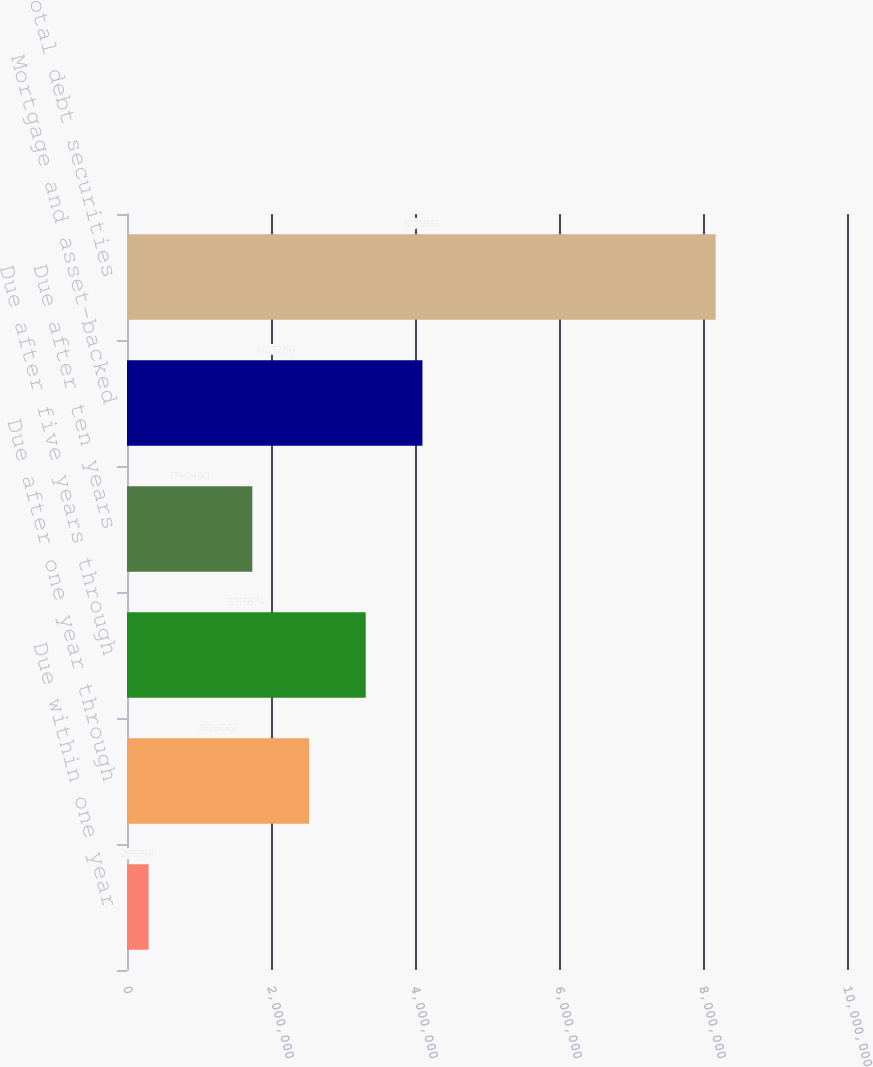Convert chart. <chart><loc_0><loc_0><loc_500><loc_500><bar_chart><fcel>Due within one year<fcel>Due after one year through<fcel>Due after five years through<fcel>Due after ten years<fcel>Mortgage and asset-backed<fcel>Total debt securities<nl><fcel>299861<fcel>2.52806e+06<fcel>3.31567e+06<fcel>1.74045e+06<fcel>4.10329e+06<fcel>8.17598e+06<nl></chart> 